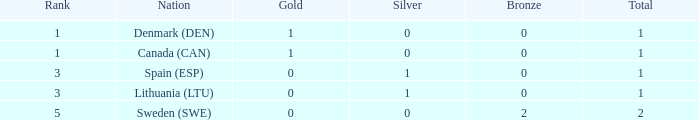What is the count of gold medals won by lithuania (ltu) when the overall total exceeds 1? None. 